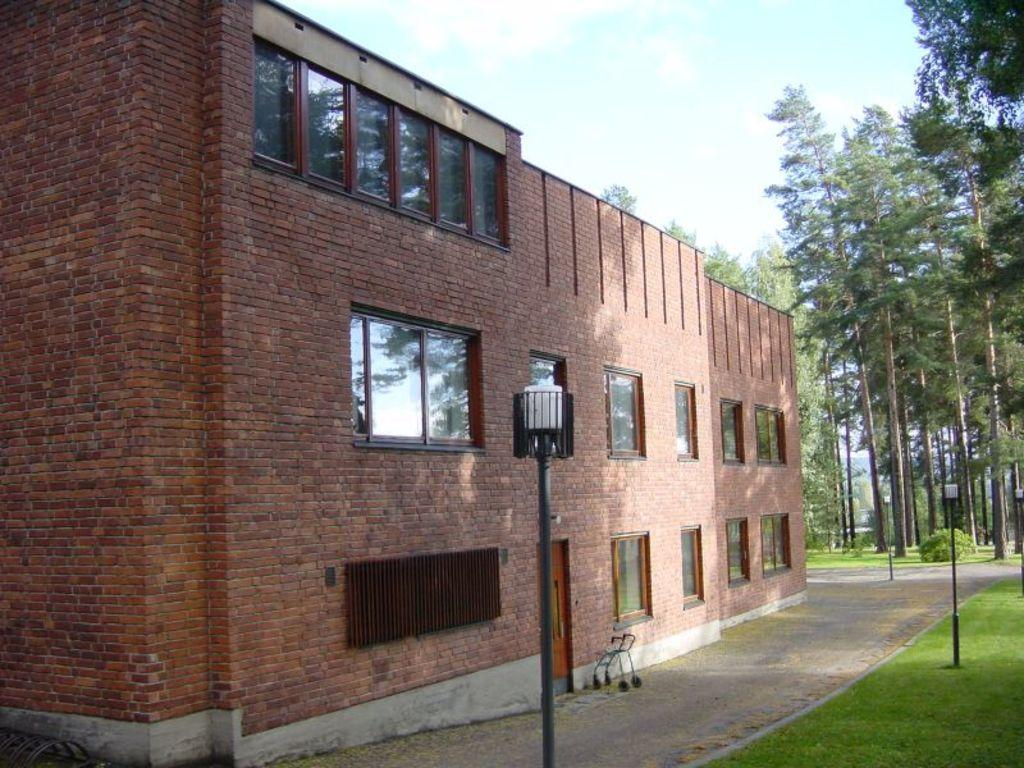What type of structure is present in the image? There is a building in the image. What is the color of the building? The building is brown in color. Are there any openings in the building? Yes, there are windows in the building. What other objects can be seen in the image? There are light poles and trees in the image. What is the color of the trees? The trees are green in color. What can be seen in the sky in the image? The sky has both white and blue colors. How many leaves can be seen on the rat in the image? There is no rat present in the image, and therefore no leaves can be seen on it. 